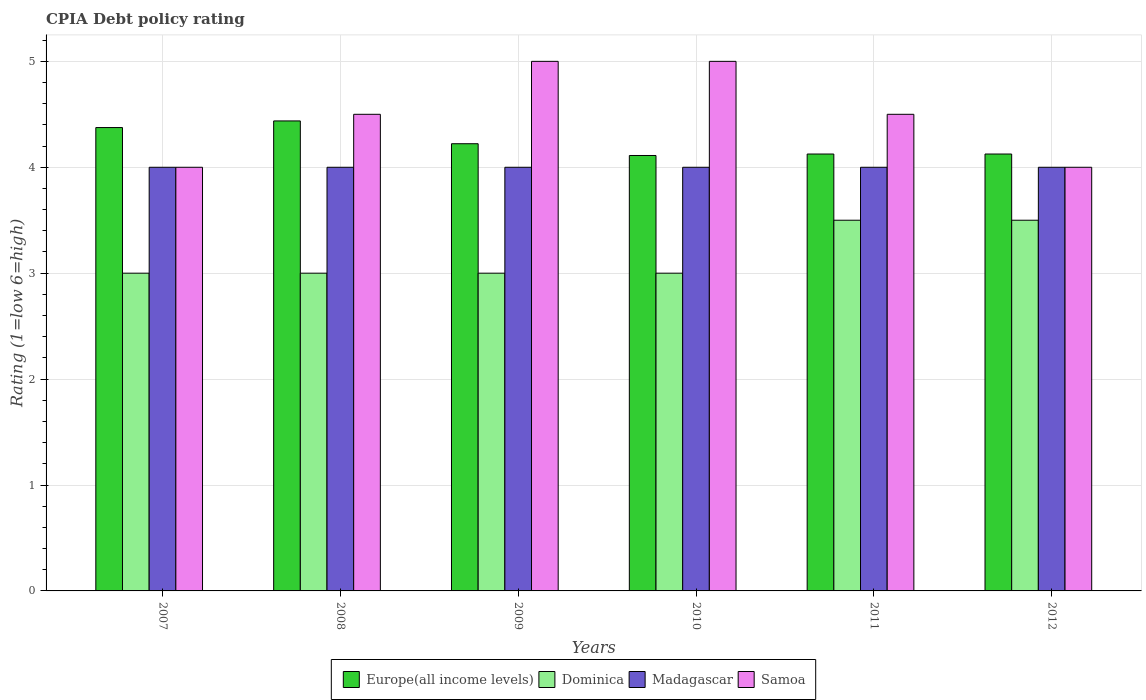How many groups of bars are there?
Your answer should be very brief. 6. Are the number of bars per tick equal to the number of legend labels?
Give a very brief answer. Yes. How many bars are there on the 3rd tick from the right?
Offer a very short reply. 4. What is the CPIA rating in Samoa in 2007?
Keep it short and to the point. 4. Across all years, what is the maximum CPIA rating in Europe(all income levels)?
Provide a succinct answer. 4.44. In which year was the CPIA rating in Madagascar minimum?
Make the answer very short. 2007. What is the difference between the CPIA rating in Samoa in 2008 and that in 2012?
Your answer should be very brief. 0.5. What is the difference between the CPIA rating in Dominica in 2008 and the CPIA rating in Europe(all income levels) in 2010?
Ensure brevity in your answer.  -1.11. In how many years, is the CPIA rating in Europe(all income levels) greater than 3.2?
Provide a succinct answer. 6. What is the ratio of the CPIA rating in Europe(all income levels) in 2009 to that in 2012?
Make the answer very short. 1.02. Is the CPIA rating in Europe(all income levels) in 2011 less than that in 2012?
Your answer should be compact. No. What is the difference between the highest and the second highest CPIA rating in Samoa?
Offer a terse response. 0. Is it the case that in every year, the sum of the CPIA rating in Dominica and CPIA rating in Samoa is greater than the sum of CPIA rating in Europe(all income levels) and CPIA rating in Madagascar?
Ensure brevity in your answer.  No. What does the 4th bar from the left in 2010 represents?
Keep it short and to the point. Samoa. What does the 3rd bar from the right in 2009 represents?
Provide a short and direct response. Dominica. Is it the case that in every year, the sum of the CPIA rating in Samoa and CPIA rating in Dominica is greater than the CPIA rating in Madagascar?
Ensure brevity in your answer.  Yes. How many bars are there?
Your answer should be compact. 24. Does the graph contain any zero values?
Your answer should be compact. No. Does the graph contain grids?
Offer a very short reply. Yes. What is the title of the graph?
Provide a short and direct response. CPIA Debt policy rating. Does "Syrian Arab Republic" appear as one of the legend labels in the graph?
Offer a terse response. No. What is the Rating (1=low 6=high) in Europe(all income levels) in 2007?
Ensure brevity in your answer.  4.38. What is the Rating (1=low 6=high) in Dominica in 2007?
Your answer should be very brief. 3. What is the Rating (1=low 6=high) of Europe(all income levels) in 2008?
Offer a terse response. 4.44. What is the Rating (1=low 6=high) of Dominica in 2008?
Offer a very short reply. 3. What is the Rating (1=low 6=high) in Samoa in 2008?
Keep it short and to the point. 4.5. What is the Rating (1=low 6=high) in Europe(all income levels) in 2009?
Give a very brief answer. 4.22. What is the Rating (1=low 6=high) in Dominica in 2009?
Offer a terse response. 3. What is the Rating (1=low 6=high) in Europe(all income levels) in 2010?
Make the answer very short. 4.11. What is the Rating (1=low 6=high) in Dominica in 2010?
Ensure brevity in your answer.  3. What is the Rating (1=low 6=high) in Samoa in 2010?
Your response must be concise. 5. What is the Rating (1=low 6=high) of Europe(all income levels) in 2011?
Give a very brief answer. 4.12. What is the Rating (1=low 6=high) of Europe(all income levels) in 2012?
Offer a very short reply. 4.12. What is the Rating (1=low 6=high) of Madagascar in 2012?
Give a very brief answer. 4. Across all years, what is the maximum Rating (1=low 6=high) in Europe(all income levels)?
Make the answer very short. 4.44. Across all years, what is the maximum Rating (1=low 6=high) of Dominica?
Your response must be concise. 3.5. Across all years, what is the maximum Rating (1=low 6=high) in Samoa?
Offer a very short reply. 5. Across all years, what is the minimum Rating (1=low 6=high) of Europe(all income levels)?
Give a very brief answer. 4.11. What is the total Rating (1=low 6=high) of Europe(all income levels) in the graph?
Offer a terse response. 25.4. What is the total Rating (1=low 6=high) of Dominica in the graph?
Your response must be concise. 19. What is the total Rating (1=low 6=high) of Madagascar in the graph?
Offer a very short reply. 24. What is the total Rating (1=low 6=high) in Samoa in the graph?
Ensure brevity in your answer.  27. What is the difference between the Rating (1=low 6=high) of Europe(all income levels) in 2007 and that in 2008?
Your response must be concise. -0.06. What is the difference between the Rating (1=low 6=high) in Dominica in 2007 and that in 2008?
Your answer should be very brief. 0. What is the difference between the Rating (1=low 6=high) in Madagascar in 2007 and that in 2008?
Provide a succinct answer. 0. What is the difference between the Rating (1=low 6=high) in Samoa in 2007 and that in 2008?
Your answer should be very brief. -0.5. What is the difference between the Rating (1=low 6=high) of Europe(all income levels) in 2007 and that in 2009?
Keep it short and to the point. 0.15. What is the difference between the Rating (1=low 6=high) in Dominica in 2007 and that in 2009?
Provide a succinct answer. 0. What is the difference between the Rating (1=low 6=high) in Europe(all income levels) in 2007 and that in 2010?
Make the answer very short. 0.26. What is the difference between the Rating (1=low 6=high) of Dominica in 2007 and that in 2010?
Ensure brevity in your answer.  0. What is the difference between the Rating (1=low 6=high) in Europe(all income levels) in 2007 and that in 2011?
Your answer should be compact. 0.25. What is the difference between the Rating (1=low 6=high) in Madagascar in 2007 and that in 2011?
Provide a short and direct response. 0. What is the difference between the Rating (1=low 6=high) in Europe(all income levels) in 2007 and that in 2012?
Offer a very short reply. 0.25. What is the difference between the Rating (1=low 6=high) in Dominica in 2007 and that in 2012?
Give a very brief answer. -0.5. What is the difference between the Rating (1=low 6=high) of Samoa in 2007 and that in 2012?
Offer a very short reply. 0. What is the difference between the Rating (1=low 6=high) in Europe(all income levels) in 2008 and that in 2009?
Give a very brief answer. 0.22. What is the difference between the Rating (1=low 6=high) in Madagascar in 2008 and that in 2009?
Make the answer very short. 0. What is the difference between the Rating (1=low 6=high) in Samoa in 2008 and that in 2009?
Give a very brief answer. -0.5. What is the difference between the Rating (1=low 6=high) in Europe(all income levels) in 2008 and that in 2010?
Offer a very short reply. 0.33. What is the difference between the Rating (1=low 6=high) of Dominica in 2008 and that in 2010?
Make the answer very short. 0. What is the difference between the Rating (1=low 6=high) in Madagascar in 2008 and that in 2010?
Make the answer very short. 0. What is the difference between the Rating (1=low 6=high) in Samoa in 2008 and that in 2010?
Keep it short and to the point. -0.5. What is the difference between the Rating (1=low 6=high) in Europe(all income levels) in 2008 and that in 2011?
Offer a very short reply. 0.31. What is the difference between the Rating (1=low 6=high) in Dominica in 2008 and that in 2011?
Offer a very short reply. -0.5. What is the difference between the Rating (1=low 6=high) in Madagascar in 2008 and that in 2011?
Keep it short and to the point. 0. What is the difference between the Rating (1=low 6=high) of Samoa in 2008 and that in 2011?
Ensure brevity in your answer.  0. What is the difference between the Rating (1=low 6=high) of Europe(all income levels) in 2008 and that in 2012?
Ensure brevity in your answer.  0.31. What is the difference between the Rating (1=low 6=high) in Madagascar in 2008 and that in 2012?
Offer a terse response. 0. What is the difference between the Rating (1=low 6=high) in Europe(all income levels) in 2009 and that in 2011?
Your answer should be compact. 0.1. What is the difference between the Rating (1=low 6=high) in Europe(all income levels) in 2009 and that in 2012?
Your answer should be very brief. 0.1. What is the difference between the Rating (1=low 6=high) in Dominica in 2009 and that in 2012?
Offer a very short reply. -0.5. What is the difference between the Rating (1=low 6=high) in Europe(all income levels) in 2010 and that in 2011?
Provide a succinct answer. -0.01. What is the difference between the Rating (1=low 6=high) in Madagascar in 2010 and that in 2011?
Ensure brevity in your answer.  0. What is the difference between the Rating (1=low 6=high) in Samoa in 2010 and that in 2011?
Give a very brief answer. 0.5. What is the difference between the Rating (1=low 6=high) in Europe(all income levels) in 2010 and that in 2012?
Keep it short and to the point. -0.01. What is the difference between the Rating (1=low 6=high) of Europe(all income levels) in 2011 and that in 2012?
Provide a short and direct response. 0. What is the difference between the Rating (1=low 6=high) in Dominica in 2011 and that in 2012?
Offer a very short reply. 0. What is the difference between the Rating (1=low 6=high) of Madagascar in 2011 and that in 2012?
Provide a short and direct response. 0. What is the difference between the Rating (1=low 6=high) of Europe(all income levels) in 2007 and the Rating (1=low 6=high) of Dominica in 2008?
Your answer should be very brief. 1.38. What is the difference between the Rating (1=low 6=high) in Europe(all income levels) in 2007 and the Rating (1=low 6=high) in Samoa in 2008?
Offer a terse response. -0.12. What is the difference between the Rating (1=low 6=high) of Dominica in 2007 and the Rating (1=low 6=high) of Madagascar in 2008?
Your response must be concise. -1. What is the difference between the Rating (1=low 6=high) in Europe(all income levels) in 2007 and the Rating (1=low 6=high) in Dominica in 2009?
Ensure brevity in your answer.  1.38. What is the difference between the Rating (1=low 6=high) in Europe(all income levels) in 2007 and the Rating (1=low 6=high) in Madagascar in 2009?
Provide a short and direct response. 0.38. What is the difference between the Rating (1=low 6=high) in Europe(all income levels) in 2007 and the Rating (1=low 6=high) in Samoa in 2009?
Your answer should be very brief. -0.62. What is the difference between the Rating (1=low 6=high) of Dominica in 2007 and the Rating (1=low 6=high) of Madagascar in 2009?
Your response must be concise. -1. What is the difference between the Rating (1=low 6=high) in Europe(all income levels) in 2007 and the Rating (1=low 6=high) in Dominica in 2010?
Your answer should be very brief. 1.38. What is the difference between the Rating (1=low 6=high) in Europe(all income levels) in 2007 and the Rating (1=low 6=high) in Samoa in 2010?
Your answer should be very brief. -0.62. What is the difference between the Rating (1=low 6=high) in Dominica in 2007 and the Rating (1=low 6=high) in Madagascar in 2010?
Ensure brevity in your answer.  -1. What is the difference between the Rating (1=low 6=high) in Dominica in 2007 and the Rating (1=low 6=high) in Samoa in 2010?
Offer a terse response. -2. What is the difference between the Rating (1=low 6=high) in Europe(all income levels) in 2007 and the Rating (1=low 6=high) in Madagascar in 2011?
Keep it short and to the point. 0.38. What is the difference between the Rating (1=low 6=high) of Europe(all income levels) in 2007 and the Rating (1=low 6=high) of Samoa in 2011?
Provide a succinct answer. -0.12. What is the difference between the Rating (1=low 6=high) of Europe(all income levels) in 2007 and the Rating (1=low 6=high) of Dominica in 2012?
Your response must be concise. 0.88. What is the difference between the Rating (1=low 6=high) of Madagascar in 2007 and the Rating (1=low 6=high) of Samoa in 2012?
Keep it short and to the point. 0. What is the difference between the Rating (1=low 6=high) of Europe(all income levels) in 2008 and the Rating (1=low 6=high) of Dominica in 2009?
Give a very brief answer. 1.44. What is the difference between the Rating (1=low 6=high) in Europe(all income levels) in 2008 and the Rating (1=low 6=high) in Madagascar in 2009?
Ensure brevity in your answer.  0.44. What is the difference between the Rating (1=low 6=high) of Europe(all income levels) in 2008 and the Rating (1=low 6=high) of Samoa in 2009?
Your answer should be very brief. -0.56. What is the difference between the Rating (1=low 6=high) in Dominica in 2008 and the Rating (1=low 6=high) in Samoa in 2009?
Your response must be concise. -2. What is the difference between the Rating (1=low 6=high) in Madagascar in 2008 and the Rating (1=low 6=high) in Samoa in 2009?
Provide a short and direct response. -1. What is the difference between the Rating (1=low 6=high) in Europe(all income levels) in 2008 and the Rating (1=low 6=high) in Dominica in 2010?
Provide a succinct answer. 1.44. What is the difference between the Rating (1=low 6=high) of Europe(all income levels) in 2008 and the Rating (1=low 6=high) of Madagascar in 2010?
Provide a succinct answer. 0.44. What is the difference between the Rating (1=low 6=high) in Europe(all income levels) in 2008 and the Rating (1=low 6=high) in Samoa in 2010?
Make the answer very short. -0.56. What is the difference between the Rating (1=low 6=high) in Europe(all income levels) in 2008 and the Rating (1=low 6=high) in Madagascar in 2011?
Your answer should be compact. 0.44. What is the difference between the Rating (1=low 6=high) in Europe(all income levels) in 2008 and the Rating (1=low 6=high) in Samoa in 2011?
Your response must be concise. -0.06. What is the difference between the Rating (1=low 6=high) in Dominica in 2008 and the Rating (1=low 6=high) in Madagascar in 2011?
Provide a short and direct response. -1. What is the difference between the Rating (1=low 6=high) in Madagascar in 2008 and the Rating (1=low 6=high) in Samoa in 2011?
Keep it short and to the point. -0.5. What is the difference between the Rating (1=low 6=high) of Europe(all income levels) in 2008 and the Rating (1=low 6=high) of Dominica in 2012?
Provide a short and direct response. 0.94. What is the difference between the Rating (1=low 6=high) in Europe(all income levels) in 2008 and the Rating (1=low 6=high) in Madagascar in 2012?
Your response must be concise. 0.44. What is the difference between the Rating (1=low 6=high) of Europe(all income levels) in 2008 and the Rating (1=low 6=high) of Samoa in 2012?
Make the answer very short. 0.44. What is the difference between the Rating (1=low 6=high) in Europe(all income levels) in 2009 and the Rating (1=low 6=high) in Dominica in 2010?
Provide a succinct answer. 1.22. What is the difference between the Rating (1=low 6=high) of Europe(all income levels) in 2009 and the Rating (1=low 6=high) of Madagascar in 2010?
Provide a short and direct response. 0.22. What is the difference between the Rating (1=low 6=high) of Europe(all income levels) in 2009 and the Rating (1=low 6=high) of Samoa in 2010?
Offer a very short reply. -0.78. What is the difference between the Rating (1=low 6=high) of Dominica in 2009 and the Rating (1=low 6=high) of Samoa in 2010?
Give a very brief answer. -2. What is the difference between the Rating (1=low 6=high) of Madagascar in 2009 and the Rating (1=low 6=high) of Samoa in 2010?
Keep it short and to the point. -1. What is the difference between the Rating (1=low 6=high) of Europe(all income levels) in 2009 and the Rating (1=low 6=high) of Dominica in 2011?
Your answer should be compact. 0.72. What is the difference between the Rating (1=low 6=high) in Europe(all income levels) in 2009 and the Rating (1=low 6=high) in Madagascar in 2011?
Ensure brevity in your answer.  0.22. What is the difference between the Rating (1=low 6=high) in Europe(all income levels) in 2009 and the Rating (1=low 6=high) in Samoa in 2011?
Give a very brief answer. -0.28. What is the difference between the Rating (1=low 6=high) in Dominica in 2009 and the Rating (1=low 6=high) in Madagascar in 2011?
Ensure brevity in your answer.  -1. What is the difference between the Rating (1=low 6=high) in Europe(all income levels) in 2009 and the Rating (1=low 6=high) in Dominica in 2012?
Provide a short and direct response. 0.72. What is the difference between the Rating (1=low 6=high) of Europe(all income levels) in 2009 and the Rating (1=low 6=high) of Madagascar in 2012?
Provide a short and direct response. 0.22. What is the difference between the Rating (1=low 6=high) in Europe(all income levels) in 2009 and the Rating (1=low 6=high) in Samoa in 2012?
Make the answer very short. 0.22. What is the difference between the Rating (1=low 6=high) of Dominica in 2009 and the Rating (1=low 6=high) of Samoa in 2012?
Offer a very short reply. -1. What is the difference between the Rating (1=low 6=high) of Europe(all income levels) in 2010 and the Rating (1=low 6=high) of Dominica in 2011?
Your response must be concise. 0.61. What is the difference between the Rating (1=low 6=high) in Europe(all income levels) in 2010 and the Rating (1=low 6=high) in Samoa in 2011?
Make the answer very short. -0.39. What is the difference between the Rating (1=low 6=high) in Dominica in 2010 and the Rating (1=low 6=high) in Madagascar in 2011?
Your answer should be very brief. -1. What is the difference between the Rating (1=low 6=high) of Europe(all income levels) in 2010 and the Rating (1=low 6=high) of Dominica in 2012?
Keep it short and to the point. 0.61. What is the difference between the Rating (1=low 6=high) of Europe(all income levels) in 2010 and the Rating (1=low 6=high) of Samoa in 2012?
Offer a very short reply. 0.11. What is the difference between the Rating (1=low 6=high) in Madagascar in 2010 and the Rating (1=low 6=high) in Samoa in 2012?
Offer a very short reply. 0. What is the difference between the Rating (1=low 6=high) of Europe(all income levels) in 2011 and the Rating (1=low 6=high) of Dominica in 2012?
Ensure brevity in your answer.  0.62. What is the difference between the Rating (1=low 6=high) of Europe(all income levels) in 2011 and the Rating (1=low 6=high) of Madagascar in 2012?
Offer a very short reply. 0.12. What is the difference between the Rating (1=low 6=high) in Europe(all income levels) in 2011 and the Rating (1=low 6=high) in Samoa in 2012?
Offer a terse response. 0.12. What is the difference between the Rating (1=low 6=high) in Dominica in 2011 and the Rating (1=low 6=high) in Madagascar in 2012?
Give a very brief answer. -0.5. What is the average Rating (1=low 6=high) in Europe(all income levels) per year?
Ensure brevity in your answer.  4.23. What is the average Rating (1=low 6=high) in Dominica per year?
Ensure brevity in your answer.  3.17. What is the average Rating (1=low 6=high) of Madagascar per year?
Offer a terse response. 4. What is the average Rating (1=low 6=high) in Samoa per year?
Provide a succinct answer. 4.5. In the year 2007, what is the difference between the Rating (1=low 6=high) in Europe(all income levels) and Rating (1=low 6=high) in Dominica?
Provide a succinct answer. 1.38. In the year 2007, what is the difference between the Rating (1=low 6=high) in Europe(all income levels) and Rating (1=low 6=high) in Samoa?
Your answer should be very brief. 0.38. In the year 2007, what is the difference between the Rating (1=low 6=high) of Dominica and Rating (1=low 6=high) of Madagascar?
Your answer should be very brief. -1. In the year 2007, what is the difference between the Rating (1=low 6=high) of Dominica and Rating (1=low 6=high) of Samoa?
Make the answer very short. -1. In the year 2008, what is the difference between the Rating (1=low 6=high) of Europe(all income levels) and Rating (1=low 6=high) of Dominica?
Offer a very short reply. 1.44. In the year 2008, what is the difference between the Rating (1=low 6=high) of Europe(all income levels) and Rating (1=low 6=high) of Madagascar?
Provide a short and direct response. 0.44. In the year 2008, what is the difference between the Rating (1=low 6=high) of Europe(all income levels) and Rating (1=low 6=high) of Samoa?
Your answer should be very brief. -0.06. In the year 2009, what is the difference between the Rating (1=low 6=high) in Europe(all income levels) and Rating (1=low 6=high) in Dominica?
Make the answer very short. 1.22. In the year 2009, what is the difference between the Rating (1=low 6=high) of Europe(all income levels) and Rating (1=low 6=high) of Madagascar?
Give a very brief answer. 0.22. In the year 2009, what is the difference between the Rating (1=low 6=high) in Europe(all income levels) and Rating (1=low 6=high) in Samoa?
Offer a terse response. -0.78. In the year 2009, what is the difference between the Rating (1=low 6=high) in Dominica and Rating (1=low 6=high) in Madagascar?
Your answer should be compact. -1. In the year 2009, what is the difference between the Rating (1=low 6=high) in Madagascar and Rating (1=low 6=high) in Samoa?
Make the answer very short. -1. In the year 2010, what is the difference between the Rating (1=low 6=high) of Europe(all income levels) and Rating (1=low 6=high) of Madagascar?
Make the answer very short. 0.11. In the year 2010, what is the difference between the Rating (1=low 6=high) in Europe(all income levels) and Rating (1=low 6=high) in Samoa?
Ensure brevity in your answer.  -0.89. In the year 2010, what is the difference between the Rating (1=low 6=high) of Dominica and Rating (1=low 6=high) of Madagascar?
Offer a very short reply. -1. In the year 2011, what is the difference between the Rating (1=low 6=high) in Europe(all income levels) and Rating (1=low 6=high) in Dominica?
Keep it short and to the point. 0.62. In the year 2011, what is the difference between the Rating (1=low 6=high) in Europe(all income levels) and Rating (1=low 6=high) in Samoa?
Give a very brief answer. -0.38. In the year 2011, what is the difference between the Rating (1=low 6=high) in Dominica and Rating (1=low 6=high) in Madagascar?
Your answer should be compact. -0.5. In the year 2011, what is the difference between the Rating (1=low 6=high) of Dominica and Rating (1=low 6=high) of Samoa?
Your answer should be compact. -1. In the year 2012, what is the difference between the Rating (1=low 6=high) in Europe(all income levels) and Rating (1=low 6=high) in Dominica?
Your answer should be very brief. 0.62. What is the ratio of the Rating (1=low 6=high) of Europe(all income levels) in 2007 to that in 2008?
Give a very brief answer. 0.99. What is the ratio of the Rating (1=low 6=high) of Madagascar in 2007 to that in 2008?
Keep it short and to the point. 1. What is the ratio of the Rating (1=low 6=high) in Europe(all income levels) in 2007 to that in 2009?
Offer a terse response. 1.04. What is the ratio of the Rating (1=low 6=high) in Dominica in 2007 to that in 2009?
Make the answer very short. 1. What is the ratio of the Rating (1=low 6=high) in Madagascar in 2007 to that in 2009?
Ensure brevity in your answer.  1. What is the ratio of the Rating (1=low 6=high) in Europe(all income levels) in 2007 to that in 2010?
Your answer should be very brief. 1.06. What is the ratio of the Rating (1=low 6=high) of Madagascar in 2007 to that in 2010?
Your answer should be compact. 1. What is the ratio of the Rating (1=low 6=high) of Europe(all income levels) in 2007 to that in 2011?
Provide a short and direct response. 1.06. What is the ratio of the Rating (1=low 6=high) of Dominica in 2007 to that in 2011?
Ensure brevity in your answer.  0.86. What is the ratio of the Rating (1=low 6=high) of Madagascar in 2007 to that in 2011?
Your answer should be compact. 1. What is the ratio of the Rating (1=low 6=high) of Europe(all income levels) in 2007 to that in 2012?
Keep it short and to the point. 1.06. What is the ratio of the Rating (1=low 6=high) in Dominica in 2007 to that in 2012?
Provide a short and direct response. 0.86. What is the ratio of the Rating (1=low 6=high) of Europe(all income levels) in 2008 to that in 2009?
Make the answer very short. 1.05. What is the ratio of the Rating (1=low 6=high) in Madagascar in 2008 to that in 2009?
Offer a terse response. 1. What is the ratio of the Rating (1=low 6=high) in Samoa in 2008 to that in 2009?
Keep it short and to the point. 0.9. What is the ratio of the Rating (1=low 6=high) of Europe(all income levels) in 2008 to that in 2010?
Offer a terse response. 1.08. What is the ratio of the Rating (1=low 6=high) of Dominica in 2008 to that in 2010?
Give a very brief answer. 1. What is the ratio of the Rating (1=low 6=high) of Madagascar in 2008 to that in 2010?
Provide a succinct answer. 1. What is the ratio of the Rating (1=low 6=high) in Europe(all income levels) in 2008 to that in 2011?
Your answer should be very brief. 1.08. What is the ratio of the Rating (1=low 6=high) of Madagascar in 2008 to that in 2011?
Provide a short and direct response. 1. What is the ratio of the Rating (1=low 6=high) in Samoa in 2008 to that in 2011?
Offer a very short reply. 1. What is the ratio of the Rating (1=low 6=high) of Europe(all income levels) in 2008 to that in 2012?
Ensure brevity in your answer.  1.08. What is the ratio of the Rating (1=low 6=high) of Europe(all income levels) in 2009 to that in 2010?
Offer a very short reply. 1.03. What is the ratio of the Rating (1=low 6=high) in Dominica in 2009 to that in 2010?
Provide a short and direct response. 1. What is the ratio of the Rating (1=low 6=high) in Europe(all income levels) in 2009 to that in 2011?
Give a very brief answer. 1.02. What is the ratio of the Rating (1=low 6=high) of Madagascar in 2009 to that in 2011?
Ensure brevity in your answer.  1. What is the ratio of the Rating (1=low 6=high) of Europe(all income levels) in 2009 to that in 2012?
Ensure brevity in your answer.  1.02. What is the ratio of the Rating (1=low 6=high) in Madagascar in 2009 to that in 2012?
Your answer should be compact. 1. What is the ratio of the Rating (1=low 6=high) of Europe(all income levels) in 2010 to that in 2011?
Give a very brief answer. 1. What is the ratio of the Rating (1=low 6=high) in Dominica in 2010 to that in 2011?
Your answer should be compact. 0.86. What is the ratio of the Rating (1=low 6=high) in Madagascar in 2010 to that in 2012?
Offer a terse response. 1. What is the ratio of the Rating (1=low 6=high) of Samoa in 2010 to that in 2012?
Give a very brief answer. 1.25. What is the ratio of the Rating (1=low 6=high) in Europe(all income levels) in 2011 to that in 2012?
Ensure brevity in your answer.  1. What is the difference between the highest and the second highest Rating (1=low 6=high) of Europe(all income levels)?
Make the answer very short. 0.06. What is the difference between the highest and the second highest Rating (1=low 6=high) of Madagascar?
Your answer should be very brief. 0. What is the difference between the highest and the second highest Rating (1=low 6=high) in Samoa?
Offer a terse response. 0. What is the difference between the highest and the lowest Rating (1=low 6=high) of Europe(all income levels)?
Offer a very short reply. 0.33. What is the difference between the highest and the lowest Rating (1=low 6=high) in Dominica?
Ensure brevity in your answer.  0.5. What is the difference between the highest and the lowest Rating (1=low 6=high) in Madagascar?
Provide a short and direct response. 0. 